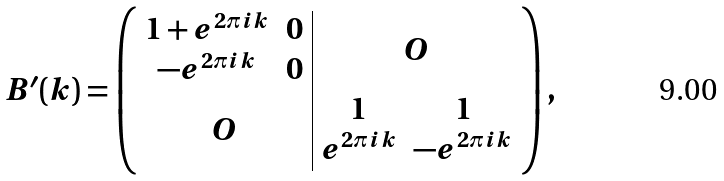Convert formula to latex. <formula><loc_0><loc_0><loc_500><loc_500>B ^ { \prime } ( k ) = \left ( \begin{array} { c | c } \begin{matrix} 1 + e ^ { 2 \pi i k } & 0 \\ - e ^ { 2 \pi i k } & 0 \end{matrix} & O \\ O & \begin{matrix} 1 & 1 \\ e ^ { 2 \pi i k } & - e ^ { 2 \pi i k } \end{matrix} \end{array} \right ) ,</formula> 